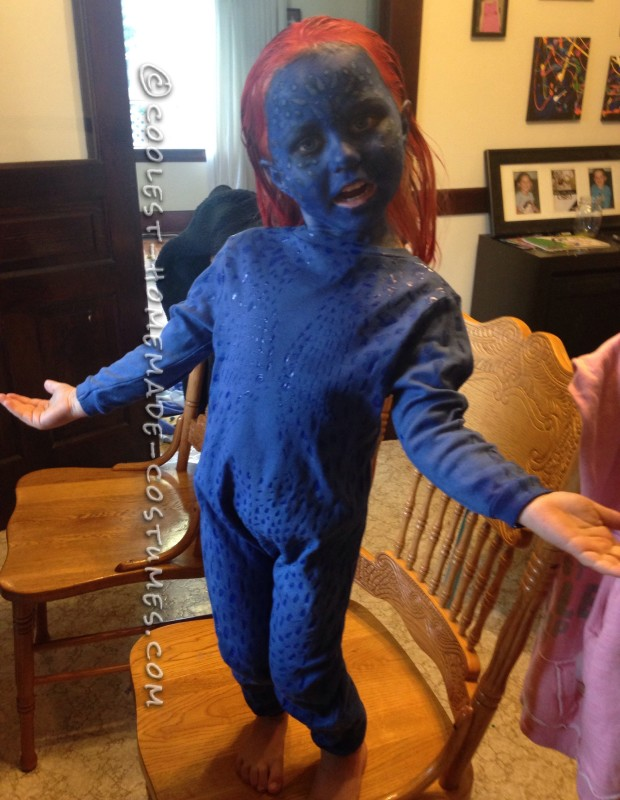What might be an interesting story involving this costume at a party? Imagine walking into a party dressed in this stunning blue costume. The moment you enter, everyone’s eyes turn to you, and whispers ripple through the crowd. Someone approaches, clearly a fan, and asks for a picture together. Throughout the night, people compliment your costume and you end up winning the best costume award! The unique look, vivid colors, and attention to detail make it a memorable evening where you get to share your passion for the character and the effort you put into creating this costume. The night ends with a great sense of accomplishment and admiration from fellow attendees. Can you write a short poem about this costume? In blue and red, a vision stands bold,
A story in fabric, a tale untold.
Bright skin of sapphire, hair aflame,
A crafted art, that earns its fame.
To parties you bring a legend's lore,
A symbol of courage and so much more.
With each intricate stitch and painted hue,
You transform a night, and dreams come true. Let's get very creative. What kind of adventures could this character go on? Picture this: in a distant galaxy where suns paint the skies with hues of blue and crimson, our character embarks on an interstellar quest. Tasked with retrieving an ancient artifact that holds the power to balance the universe, they journey through space wielding their unique blue skin as a shield against cosmic radiation. Along the way, they encounter celestial beings, navigate treacherous asteroid fields, and confront rogue space pirates. Each step of their journey is a challenge, testing their agility, strength, and wisdom. Their mission leads them to the heart of a forgotten planet, where they unlock secrets of an old civilization and ultimately, save the universe from an impending doom, becoming a legend in the process. 